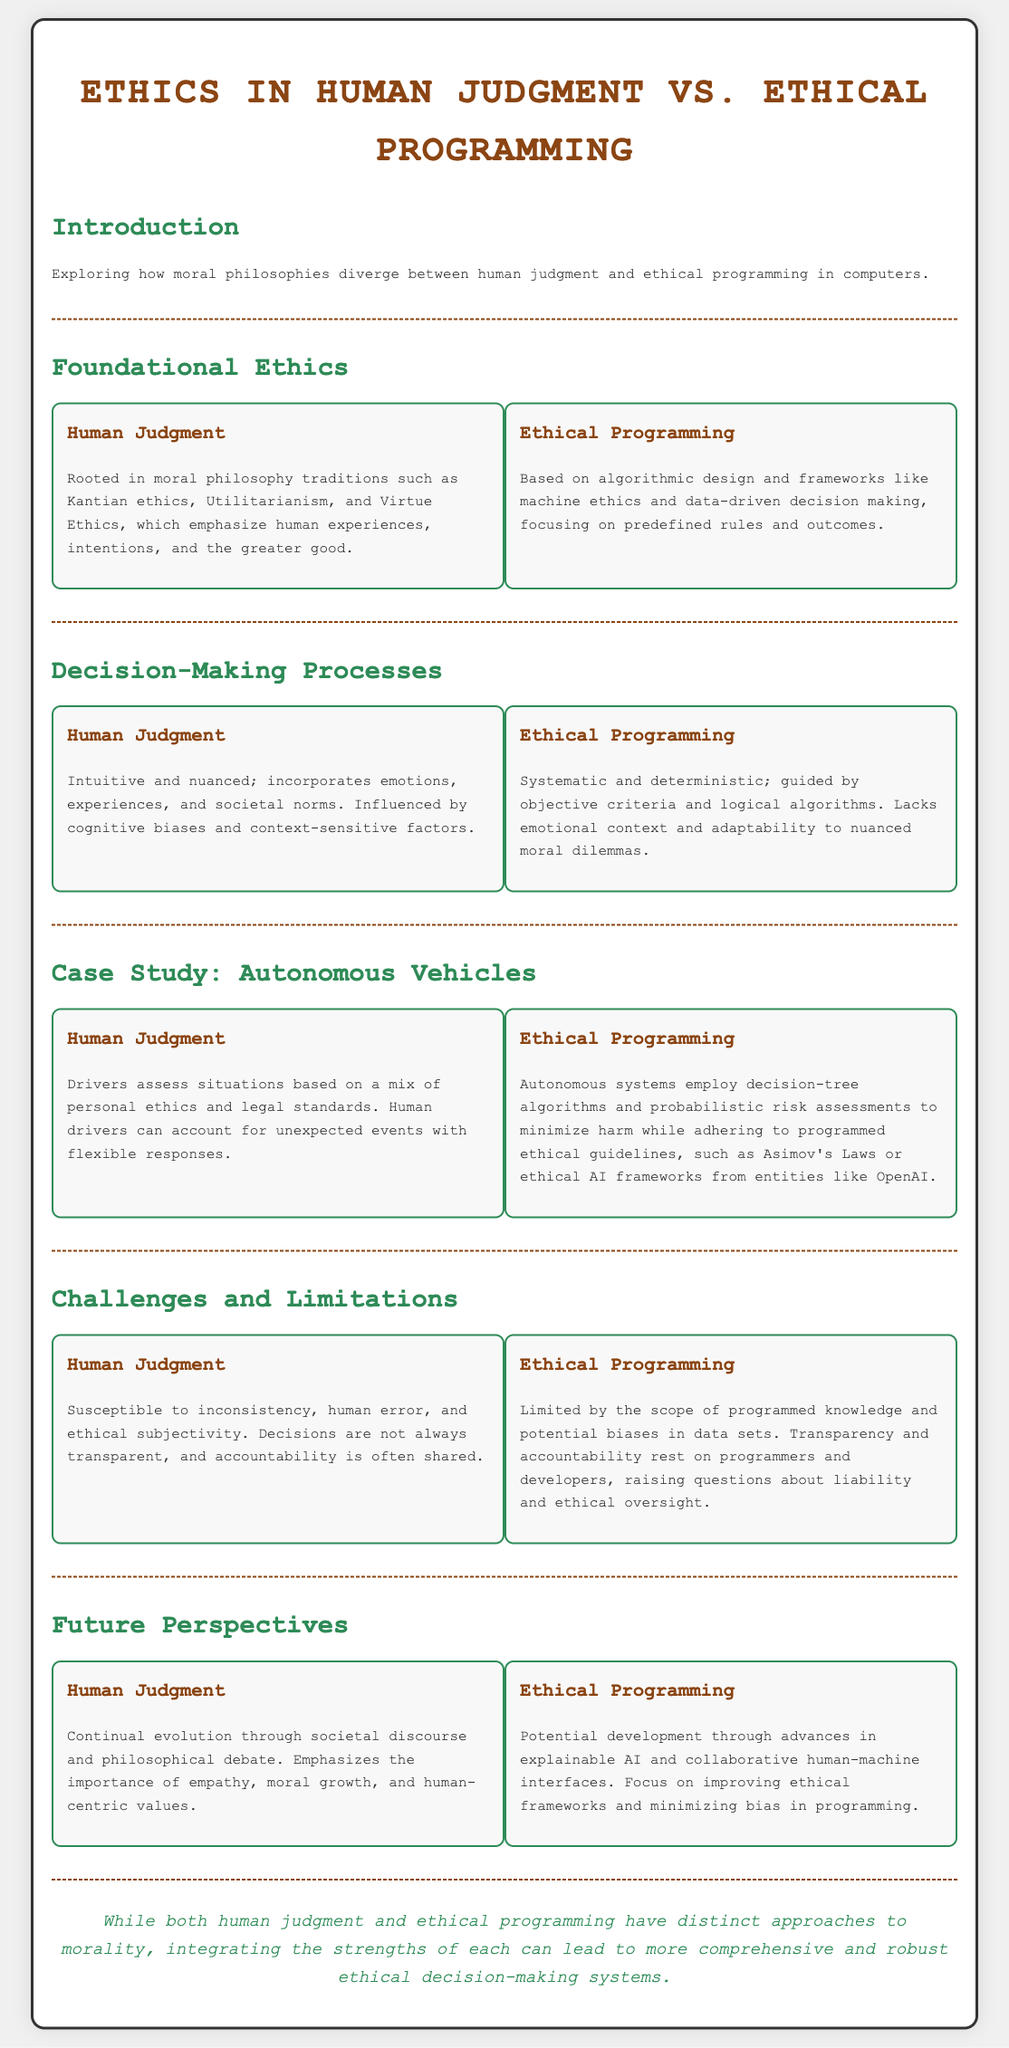What are the three moral philosophy traditions in human judgment? The document lists Kantian ethics, Utilitarianism, and Virtue Ethics as the three moral philosophy traditions in human judgment.
Answer: Kantian ethics, Utilitarianism, Virtue Ethics What are two key characteristics of ethical programming? Ethical programming is described as being based on algorithmic design and focusing on predefined rules and outcomes.
Answer: Algorithmic design, predefined rules What influences human judgment in decision-making? Human judgment is influenced by emotions, experiences, societal norms, cognitive biases, and context-sensitive factors.
Answer: Emotions, experiences, societal norms What do autonomous systems use for decision-making in ethical programming? The document indicates that autonomous systems employ decision-tree algorithms and probabilistic risk assessments.
Answer: Decision-tree algorithms, probabilistic risk assessments What challenge does human judgment face according to the document? The document points out that human judgment is susceptible to inconsistency and human error.
Answer: Inconsistency, human error What is a primary focus for future ethical programming development? The future perspectives for ethical programming emphasize improving ethical frameworks and minimizing bias in programming.
Answer: Improving ethical frameworks, minimizing bias What does the conclusion suggest about combining human judgment and ethical programming? The conclusion indicates that integrating the strengths of both can lead to more comprehensive ethical decision-making systems.
Answer: More comprehensive ethical decision-making systems What aspect of human judgment is evolving according to future perspectives? The document states that human judgment is evolving through societal discourse and philosophical debate.
Answer: Societal discourse, philosophical debate 